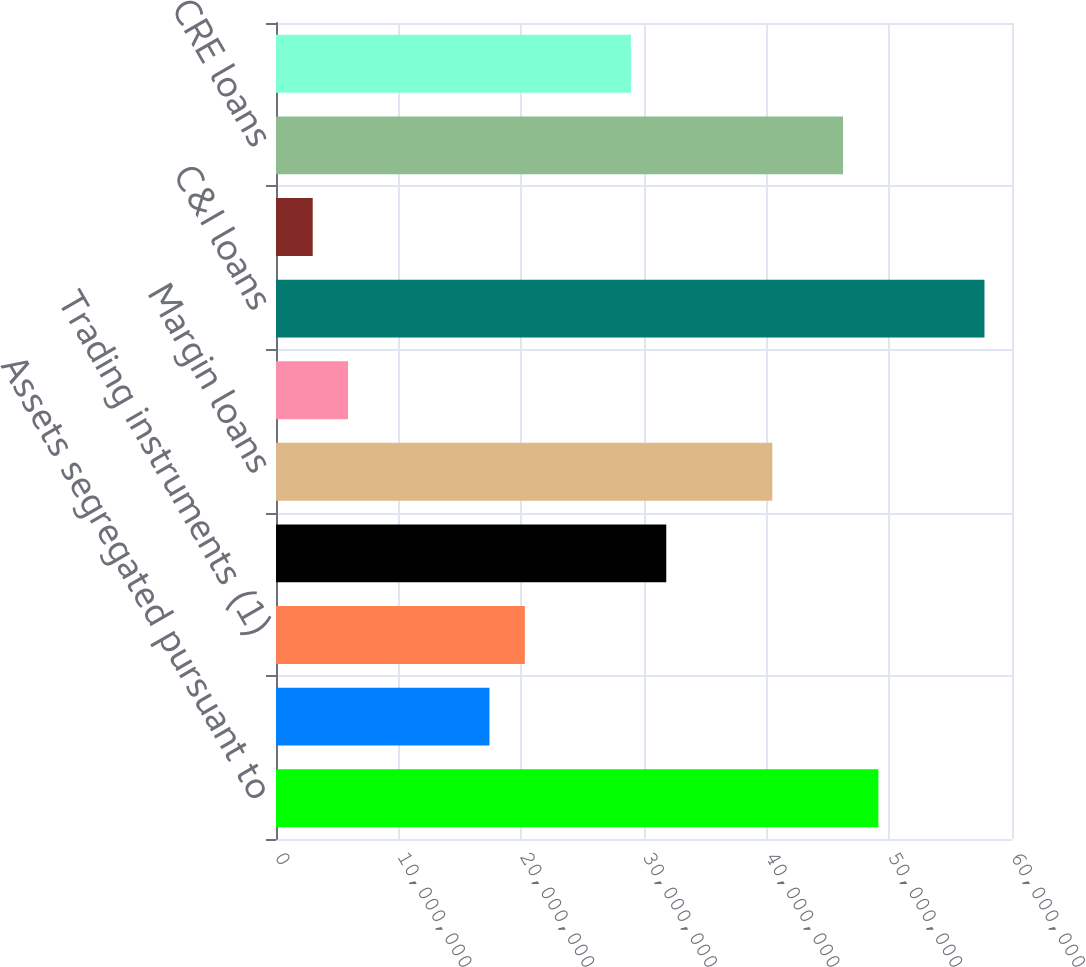Convert chart. <chart><loc_0><loc_0><loc_500><loc_500><bar_chart><fcel>Assets segregated pursuant to<fcel>Securities loaned<fcel>Trading instruments (1)<fcel>Available-for-sale securities<fcel>Margin loans<fcel>Loans held for sale<fcel>C&I loans<fcel>CRE construction loans<fcel>CRE loans<fcel>Tax-exempt loans (3)<nl><fcel>4.91085e+07<fcel>1.74039e+07<fcel>2.02861e+07<fcel>3.1815e+07<fcel>4.04618e+07<fcel>5.87489e+06<fcel>5.77552e+07<fcel>2.99266e+06<fcel>4.62262e+07<fcel>2.89328e+07<nl></chart> 